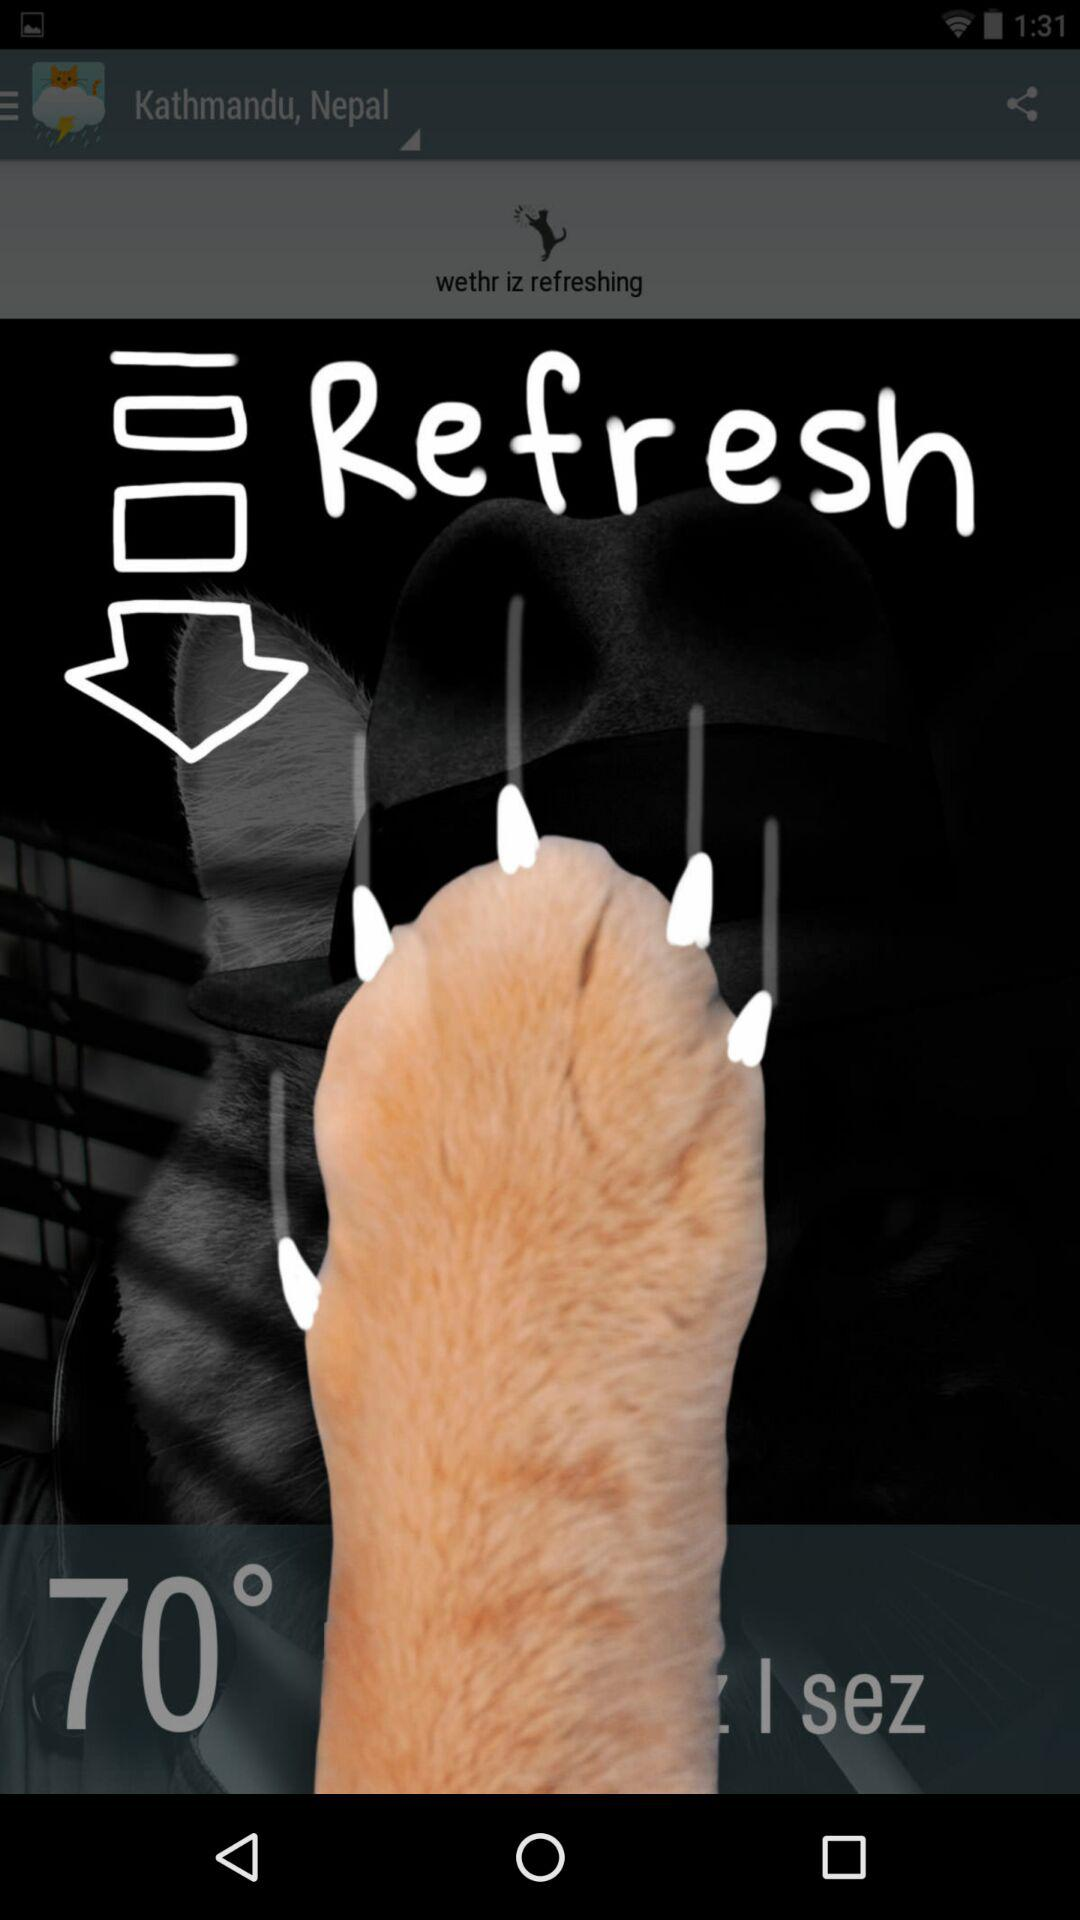Will it be 70 degrees again tomorrow?
When the provided information is insufficient, respond with <no answer>. <no answer> 